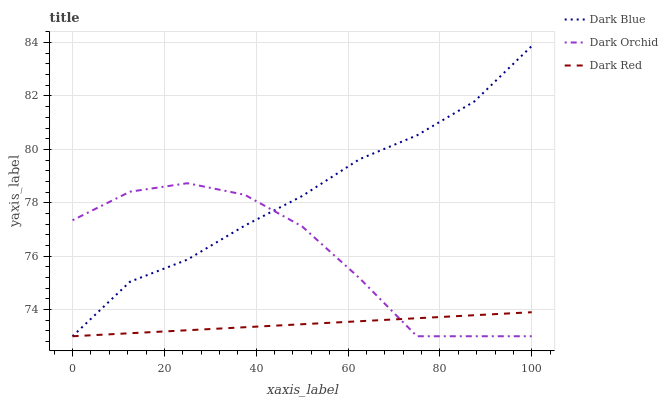Does Dark Red have the minimum area under the curve?
Answer yes or no. Yes. Does Dark Blue have the maximum area under the curve?
Answer yes or no. Yes. Does Dark Orchid have the minimum area under the curve?
Answer yes or no. No. Does Dark Orchid have the maximum area under the curve?
Answer yes or no. No. Is Dark Red the smoothest?
Answer yes or no. Yes. Is Dark Orchid the roughest?
Answer yes or no. Yes. Is Dark Orchid the smoothest?
Answer yes or no. No. Is Dark Red the roughest?
Answer yes or no. No. Does Dark Blue have the lowest value?
Answer yes or no. Yes. Does Dark Blue have the highest value?
Answer yes or no. Yes. Does Dark Orchid have the highest value?
Answer yes or no. No. Does Dark Blue intersect Dark Orchid?
Answer yes or no. Yes. Is Dark Blue less than Dark Orchid?
Answer yes or no. No. Is Dark Blue greater than Dark Orchid?
Answer yes or no. No. 